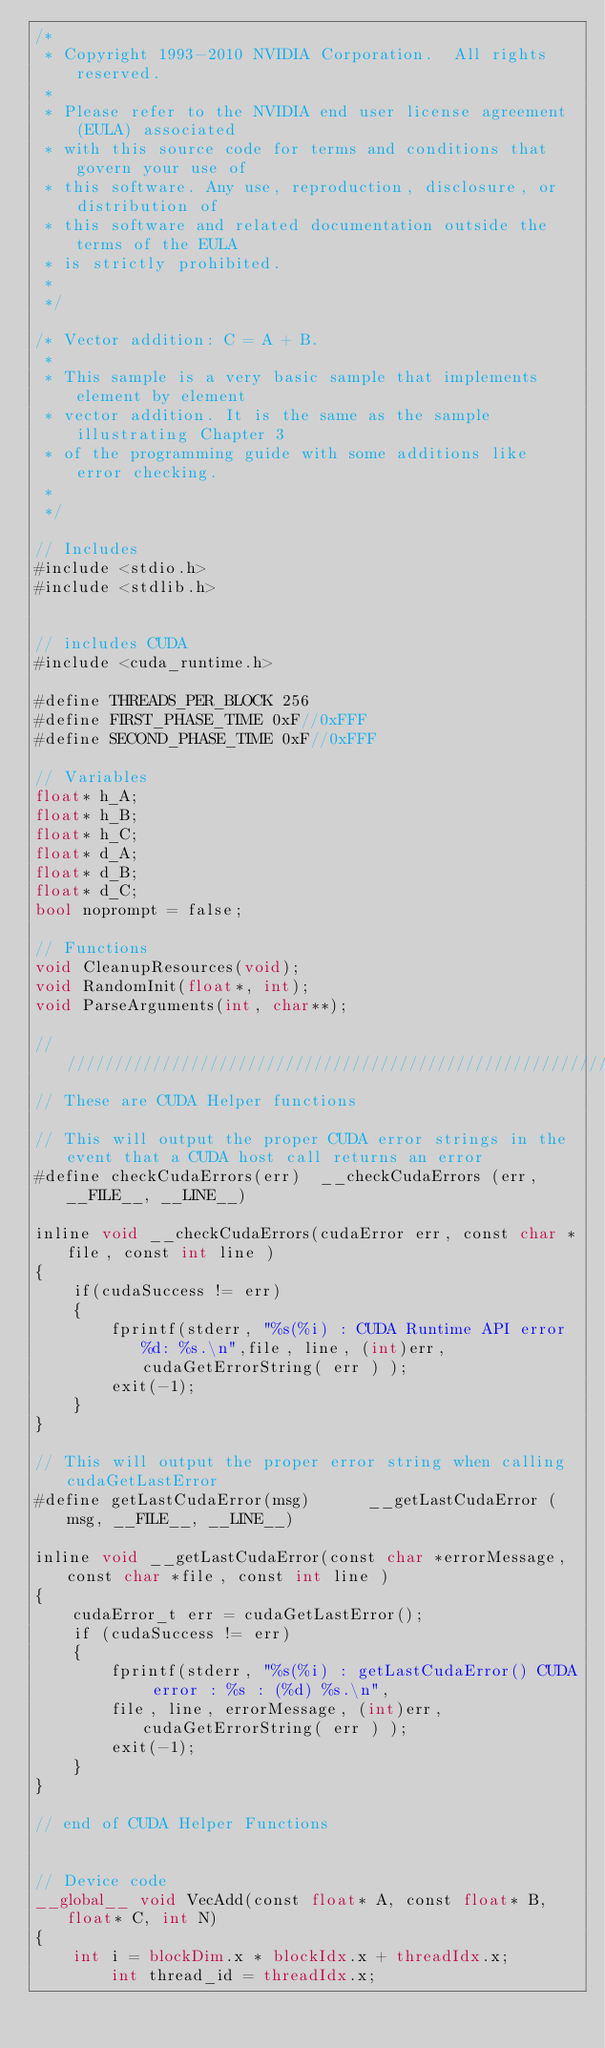Convert code to text. <code><loc_0><loc_0><loc_500><loc_500><_Cuda_>/*
 * Copyright 1993-2010 NVIDIA Corporation.  All rights reserved.
 *
 * Please refer to the NVIDIA end user license agreement (EULA) associated
 * with this source code for terms and conditions that govern your use of
 * this software. Any use, reproduction, disclosure, or distribution of
 * this software and related documentation outside the terms of the EULA
 * is strictly prohibited.
 *
 */

/* Vector addition: C = A + B.
 *
 * This sample is a very basic sample that implements element by element
 * vector addition. It is the same as the sample illustrating Chapter 3
 * of the programming guide with some additions like error checking.
 *
 */

// Includes
#include <stdio.h>
#include <stdlib.h>


// includes CUDA
#include <cuda_runtime.h>

#define THREADS_PER_BLOCK 256
#define FIRST_PHASE_TIME 0xF//0xFFF
#define SECOND_PHASE_TIME 0xF//0xFFF

// Variables
float* h_A;
float* h_B;
float* h_C;
float* d_A;
float* d_B;
float* d_C;
bool noprompt = false;

// Functions
void CleanupResources(void);
void RandomInit(float*, int);
void ParseArguments(int, char**);

////////////////////////////////////////////////////////////////////////////////
// These are CUDA Helper functions

// This will output the proper CUDA error strings in the event that a CUDA host call returns an error
#define checkCudaErrors(err)  __checkCudaErrors (err, __FILE__, __LINE__)

inline void __checkCudaErrors(cudaError err, const char *file, const int line )
{
    if(cudaSuccess != err)
    {
        fprintf(stderr, "%s(%i) : CUDA Runtime API error %d: %s.\n",file, line, (int)err, cudaGetErrorString( err ) );
        exit(-1);        
    }
}

// This will output the proper error string when calling cudaGetLastError
#define getLastCudaError(msg)      __getLastCudaError (msg, __FILE__, __LINE__)

inline void __getLastCudaError(const char *errorMessage, const char *file, const int line )
{
    cudaError_t err = cudaGetLastError();
    if (cudaSuccess != err)
    {
        fprintf(stderr, "%s(%i) : getLastCudaError() CUDA error : %s : (%d) %s.\n",
        file, line, errorMessage, (int)err, cudaGetErrorString( err ) );
        exit(-1);
    }
}

// end of CUDA Helper Functions


// Device code
__global__ void VecAdd(const float* A, const float* B, float* C, int N)
{
    int i = blockDim.x * blockIdx.x + threadIdx.x;
		int thread_id = threadIdx.x;</code> 